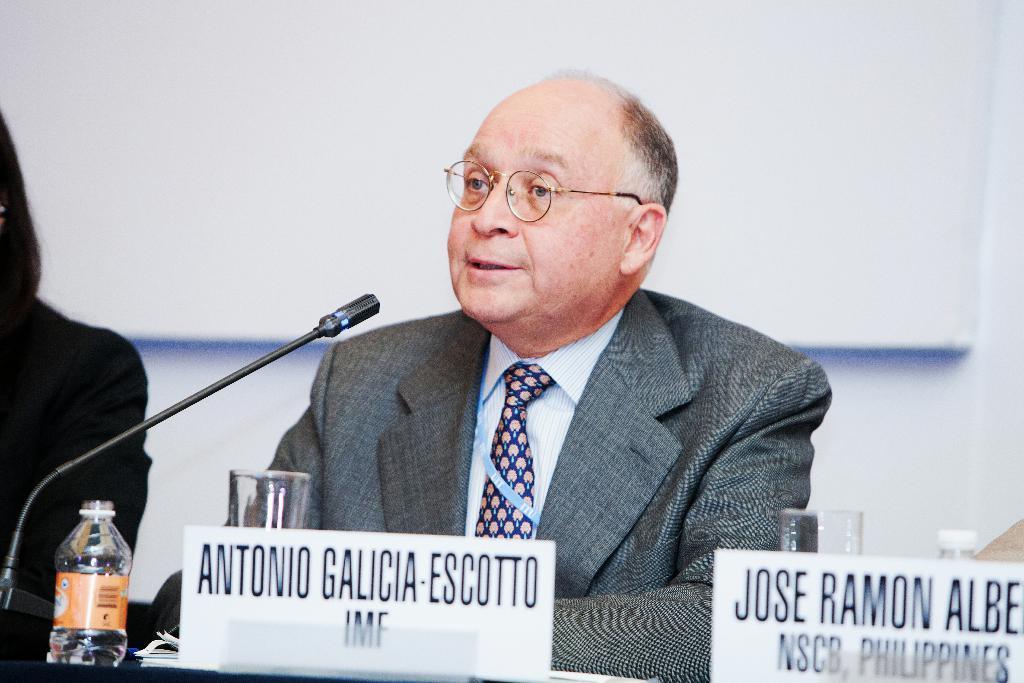Please provide a concise description of this image. In this picture a man is sitting on a chair. In front of this man there is a microphone, water bottle, glass and a name board. The left side of this man there is a woman sitting. Background of this people there is a white wall. 